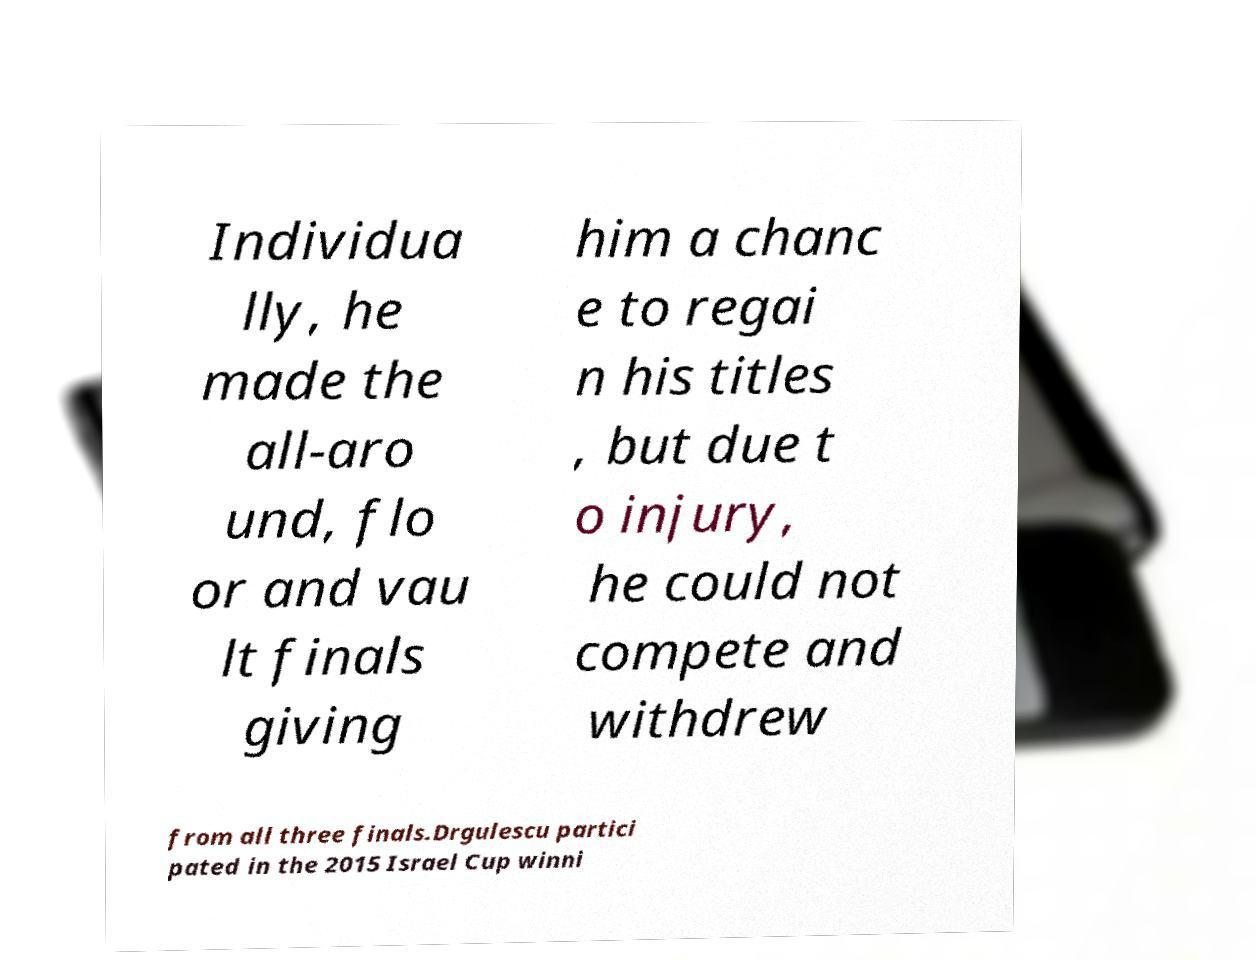I need the written content from this picture converted into text. Can you do that? Individua lly, he made the all-aro und, flo or and vau lt finals giving him a chanc e to regai n his titles , but due t o injury, he could not compete and withdrew from all three finals.Drgulescu partici pated in the 2015 Israel Cup winni 